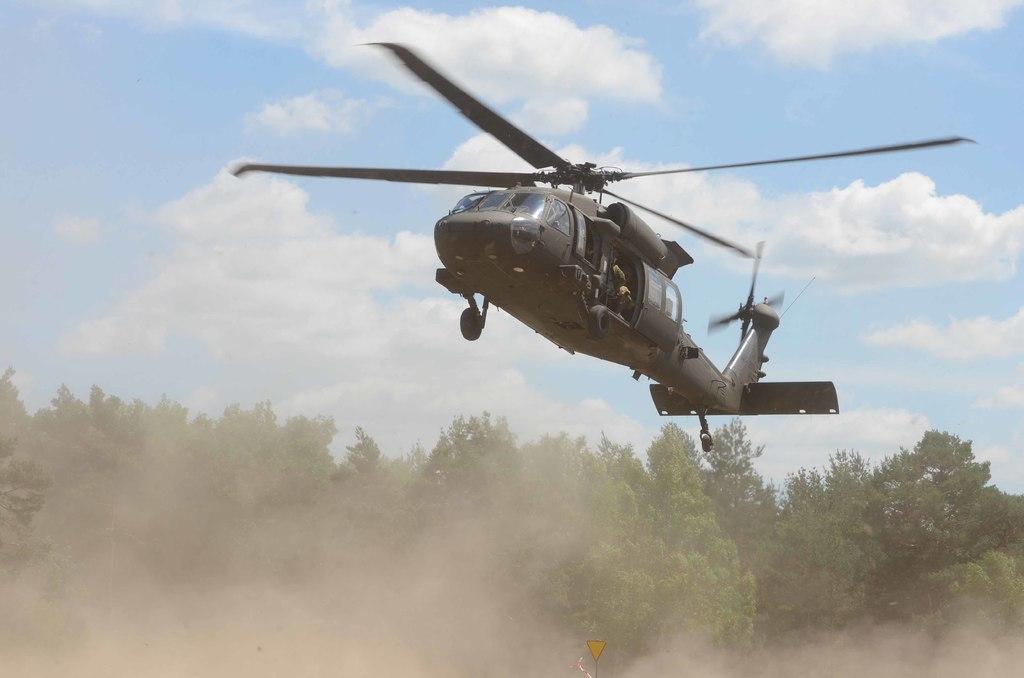Could you give a brief overview of what you see in this image? In this image we can see a flying helicopter , there are few trees, there is a sign board, and we can see clouded sky. 